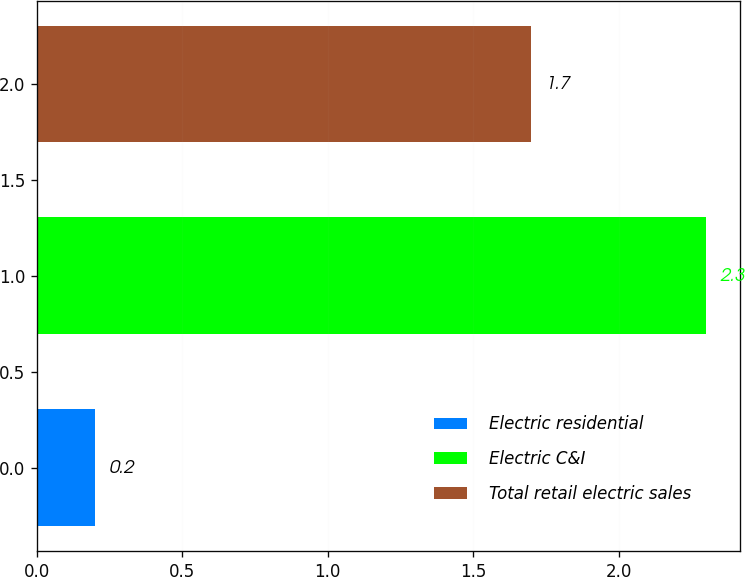Convert chart. <chart><loc_0><loc_0><loc_500><loc_500><bar_chart><fcel>Electric residential<fcel>Electric C&I<fcel>Total retail electric sales<nl><fcel>0.2<fcel>2.3<fcel>1.7<nl></chart> 